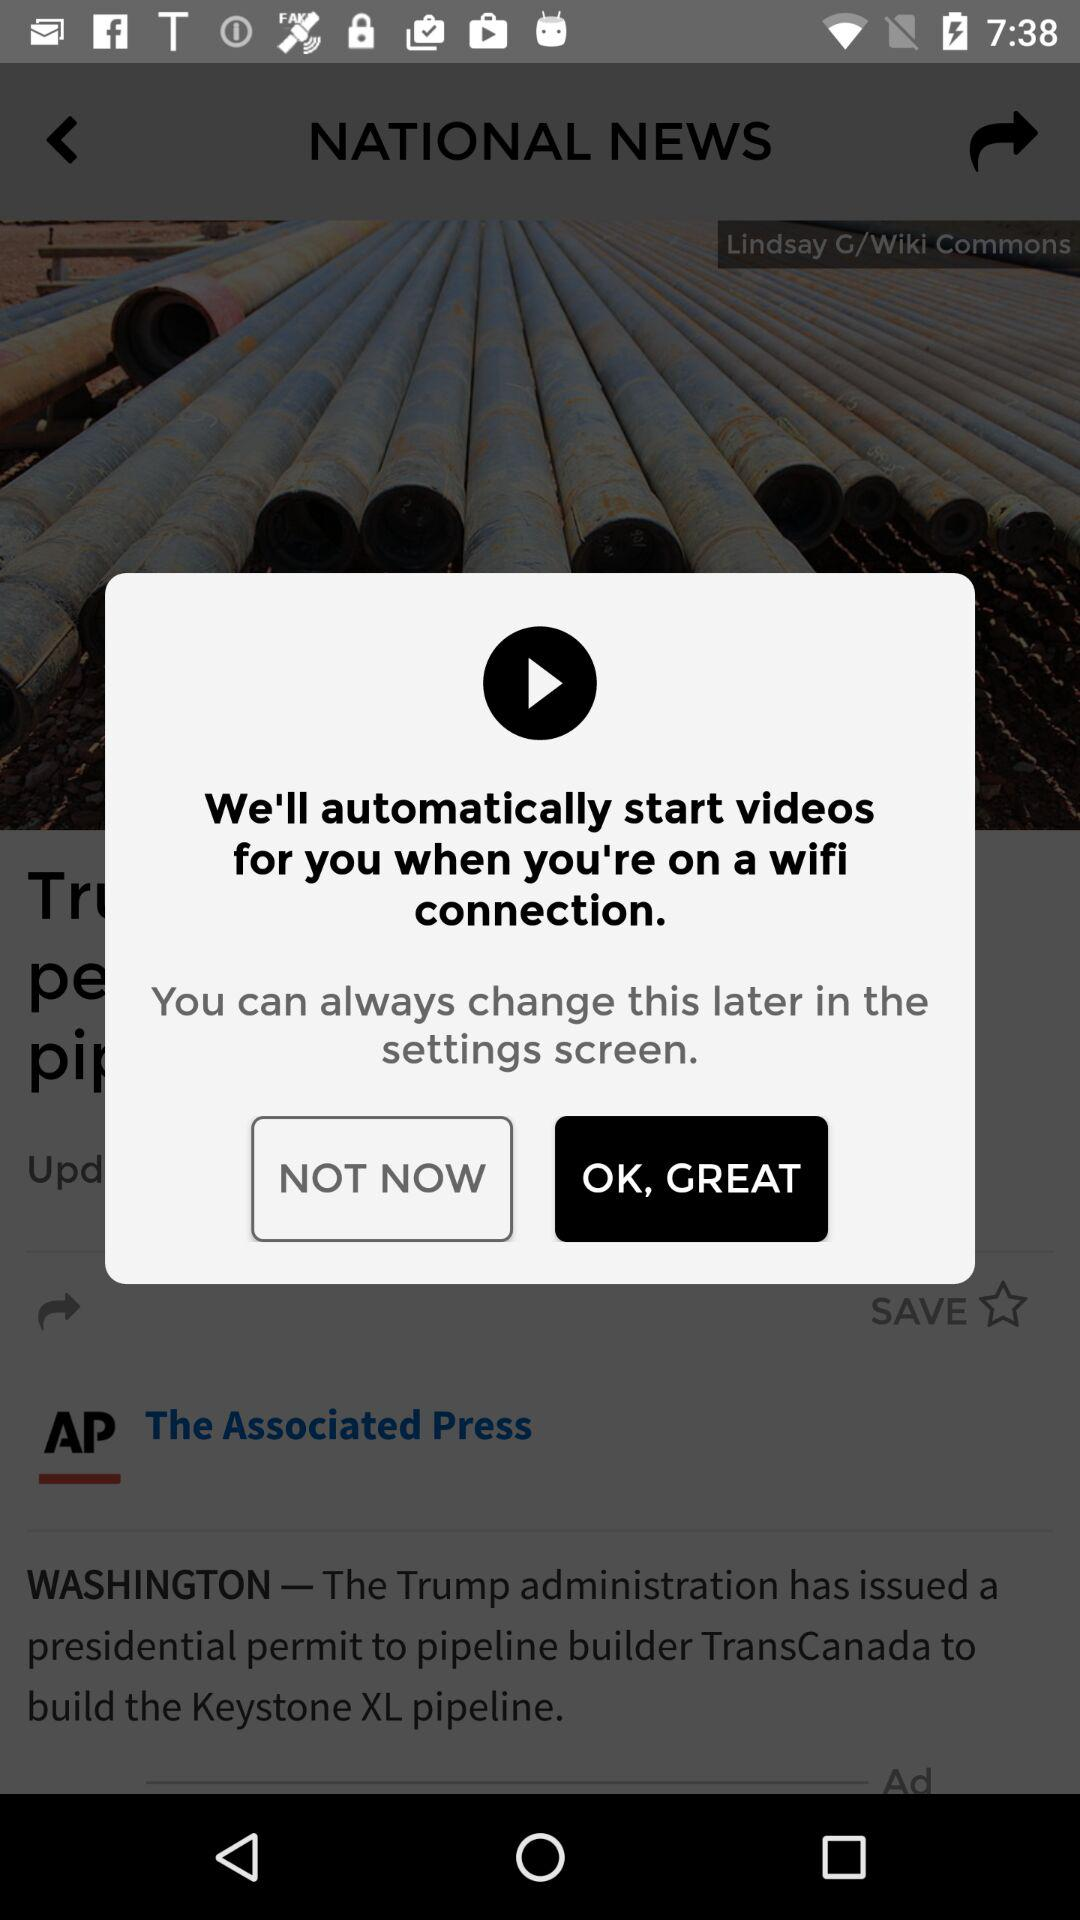What is the given location in the article? The given location is Washington. 